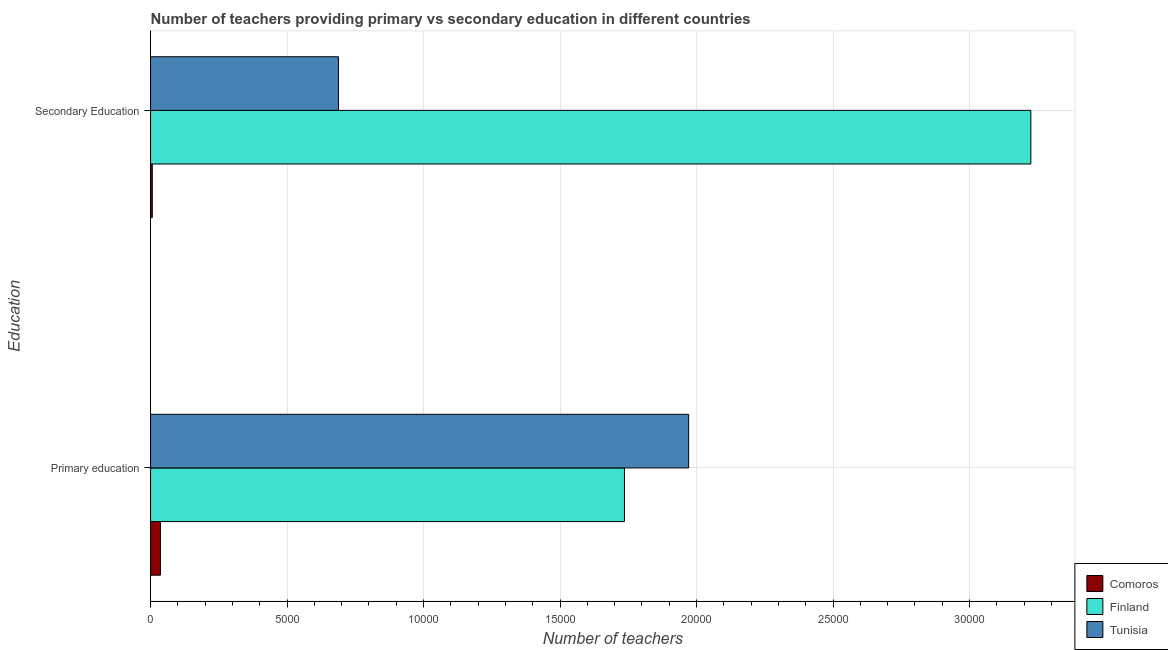How many bars are there on the 2nd tick from the top?
Ensure brevity in your answer.  3. How many bars are there on the 2nd tick from the bottom?
Your answer should be compact. 3. What is the label of the 1st group of bars from the top?
Provide a succinct answer. Secondary Education. What is the number of secondary teachers in Finland?
Offer a terse response. 3.22e+04. Across all countries, what is the maximum number of secondary teachers?
Make the answer very short. 3.22e+04. Across all countries, what is the minimum number of secondary teachers?
Make the answer very short. 63. In which country was the number of secondary teachers maximum?
Your response must be concise. Finland. In which country was the number of primary teachers minimum?
Your answer should be very brief. Comoros. What is the total number of secondary teachers in the graph?
Ensure brevity in your answer.  3.92e+04. What is the difference between the number of primary teachers in Finland and that in Comoros?
Keep it short and to the point. 1.70e+04. What is the difference between the number of secondary teachers in Tunisia and the number of primary teachers in Finland?
Offer a very short reply. -1.05e+04. What is the average number of primary teachers per country?
Ensure brevity in your answer.  1.25e+04. What is the difference between the number of secondary teachers and number of primary teachers in Finland?
Your answer should be very brief. 1.49e+04. What is the ratio of the number of secondary teachers in Tunisia to that in Comoros?
Make the answer very short. 109.25. In how many countries, is the number of secondary teachers greater than the average number of secondary teachers taken over all countries?
Your answer should be compact. 1. What does the 3rd bar from the top in Primary education represents?
Your answer should be compact. Comoros. Are all the bars in the graph horizontal?
Offer a very short reply. Yes. What is the difference between two consecutive major ticks on the X-axis?
Make the answer very short. 5000. Does the graph contain any zero values?
Keep it short and to the point. No. How are the legend labels stacked?
Your response must be concise. Vertical. What is the title of the graph?
Offer a very short reply. Number of teachers providing primary vs secondary education in different countries. What is the label or title of the X-axis?
Provide a succinct answer. Number of teachers. What is the label or title of the Y-axis?
Your answer should be compact. Education. What is the Number of teachers of Comoros in Primary education?
Offer a very short reply. 361. What is the Number of teachers in Finland in Primary education?
Your answer should be very brief. 1.74e+04. What is the Number of teachers of Tunisia in Primary education?
Make the answer very short. 1.97e+04. What is the Number of teachers of Comoros in Secondary Education?
Keep it short and to the point. 63. What is the Number of teachers of Finland in Secondary Education?
Make the answer very short. 3.22e+04. What is the Number of teachers of Tunisia in Secondary Education?
Make the answer very short. 6883. Across all Education, what is the maximum Number of teachers of Comoros?
Your answer should be compact. 361. Across all Education, what is the maximum Number of teachers in Finland?
Ensure brevity in your answer.  3.22e+04. Across all Education, what is the maximum Number of teachers of Tunisia?
Your answer should be compact. 1.97e+04. Across all Education, what is the minimum Number of teachers of Comoros?
Provide a short and direct response. 63. Across all Education, what is the minimum Number of teachers of Finland?
Offer a terse response. 1.74e+04. Across all Education, what is the minimum Number of teachers of Tunisia?
Keep it short and to the point. 6883. What is the total Number of teachers in Comoros in the graph?
Provide a short and direct response. 424. What is the total Number of teachers of Finland in the graph?
Provide a short and direct response. 4.96e+04. What is the total Number of teachers in Tunisia in the graph?
Provide a short and direct response. 2.66e+04. What is the difference between the Number of teachers in Comoros in Primary education and that in Secondary Education?
Your answer should be compact. 298. What is the difference between the Number of teachers of Finland in Primary education and that in Secondary Education?
Make the answer very short. -1.49e+04. What is the difference between the Number of teachers in Tunisia in Primary education and that in Secondary Education?
Give a very brief answer. 1.28e+04. What is the difference between the Number of teachers in Comoros in Primary education and the Number of teachers in Finland in Secondary Education?
Offer a very short reply. -3.19e+04. What is the difference between the Number of teachers of Comoros in Primary education and the Number of teachers of Tunisia in Secondary Education?
Ensure brevity in your answer.  -6522. What is the difference between the Number of teachers of Finland in Primary education and the Number of teachers of Tunisia in Secondary Education?
Give a very brief answer. 1.05e+04. What is the average Number of teachers in Comoros per Education?
Offer a very short reply. 212. What is the average Number of teachers in Finland per Education?
Provide a short and direct response. 2.48e+04. What is the average Number of teachers in Tunisia per Education?
Your answer should be compact. 1.33e+04. What is the difference between the Number of teachers in Comoros and Number of teachers in Finland in Primary education?
Offer a very short reply. -1.70e+04. What is the difference between the Number of teachers of Comoros and Number of teachers of Tunisia in Primary education?
Your response must be concise. -1.94e+04. What is the difference between the Number of teachers in Finland and Number of teachers in Tunisia in Primary education?
Keep it short and to the point. -2352. What is the difference between the Number of teachers of Comoros and Number of teachers of Finland in Secondary Education?
Keep it short and to the point. -3.22e+04. What is the difference between the Number of teachers in Comoros and Number of teachers in Tunisia in Secondary Education?
Make the answer very short. -6820. What is the difference between the Number of teachers in Finland and Number of teachers in Tunisia in Secondary Education?
Provide a succinct answer. 2.54e+04. What is the ratio of the Number of teachers in Comoros in Primary education to that in Secondary Education?
Offer a very short reply. 5.73. What is the ratio of the Number of teachers in Finland in Primary education to that in Secondary Education?
Provide a succinct answer. 0.54. What is the ratio of the Number of teachers in Tunisia in Primary education to that in Secondary Education?
Provide a succinct answer. 2.86. What is the difference between the highest and the second highest Number of teachers in Comoros?
Your response must be concise. 298. What is the difference between the highest and the second highest Number of teachers of Finland?
Make the answer very short. 1.49e+04. What is the difference between the highest and the second highest Number of teachers in Tunisia?
Your response must be concise. 1.28e+04. What is the difference between the highest and the lowest Number of teachers in Comoros?
Make the answer very short. 298. What is the difference between the highest and the lowest Number of teachers of Finland?
Offer a terse response. 1.49e+04. What is the difference between the highest and the lowest Number of teachers of Tunisia?
Your response must be concise. 1.28e+04. 